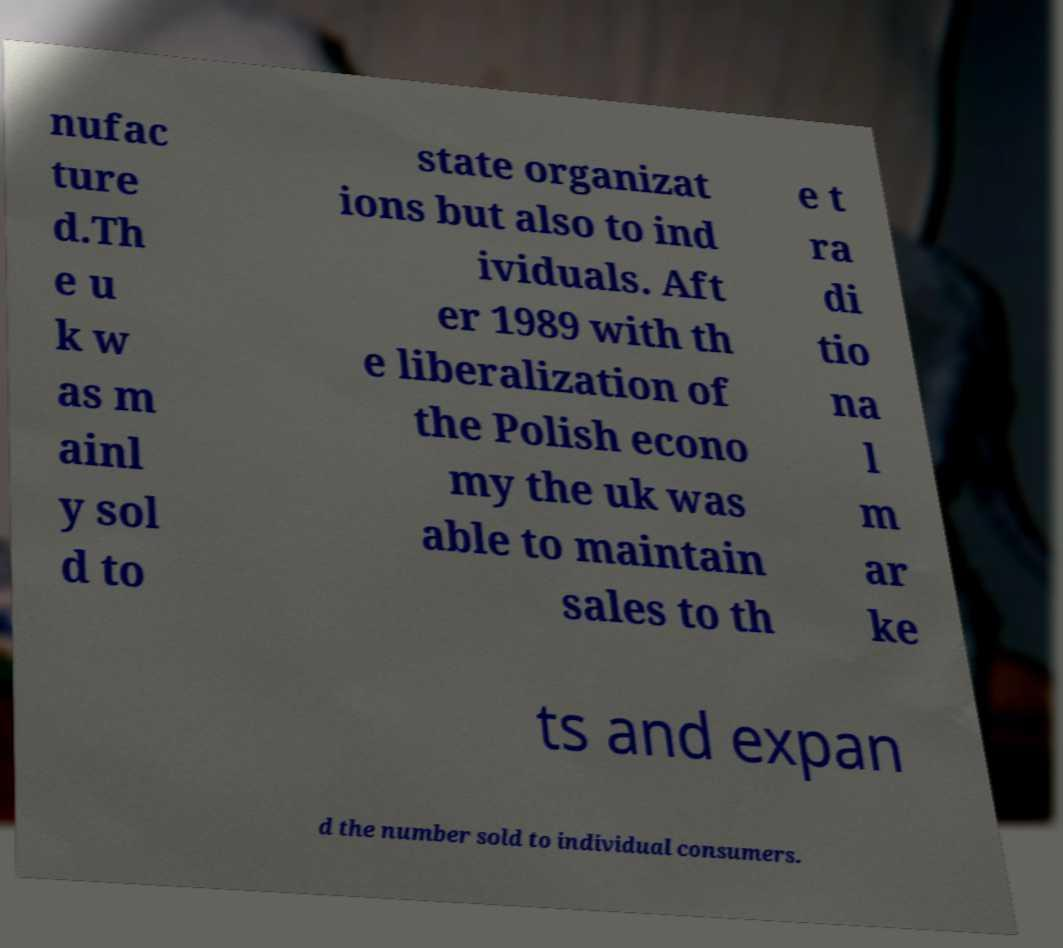I need the written content from this picture converted into text. Can you do that? nufac ture d.Th e u k w as m ainl y sol d to state organizat ions but also to ind ividuals. Aft er 1989 with th e liberalization of the Polish econo my the uk was able to maintain sales to th e t ra di tio na l m ar ke ts and expan d the number sold to individual consumers. 